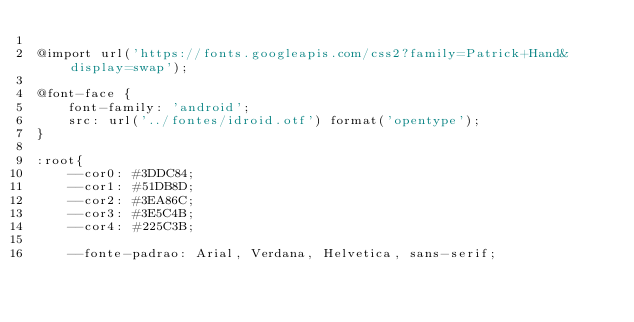Convert code to text. <code><loc_0><loc_0><loc_500><loc_500><_CSS_>
@import url('https://fonts.googleapis.com/css2?family=Patrick+Hand&display=swap');

@font-face {
    font-family: 'android';
    src: url('../fontes/idroid.otf') format('opentype');
}

:root{
    --cor0: #3DDC84;
    --cor1: #51DB8D;
    --cor2: #3EA86C;
    --cor3: #3E5C4B;
    --cor4: #225C3B;

    --fonte-padrao: Arial, Verdana, Helvetica, sans-serif;</code> 